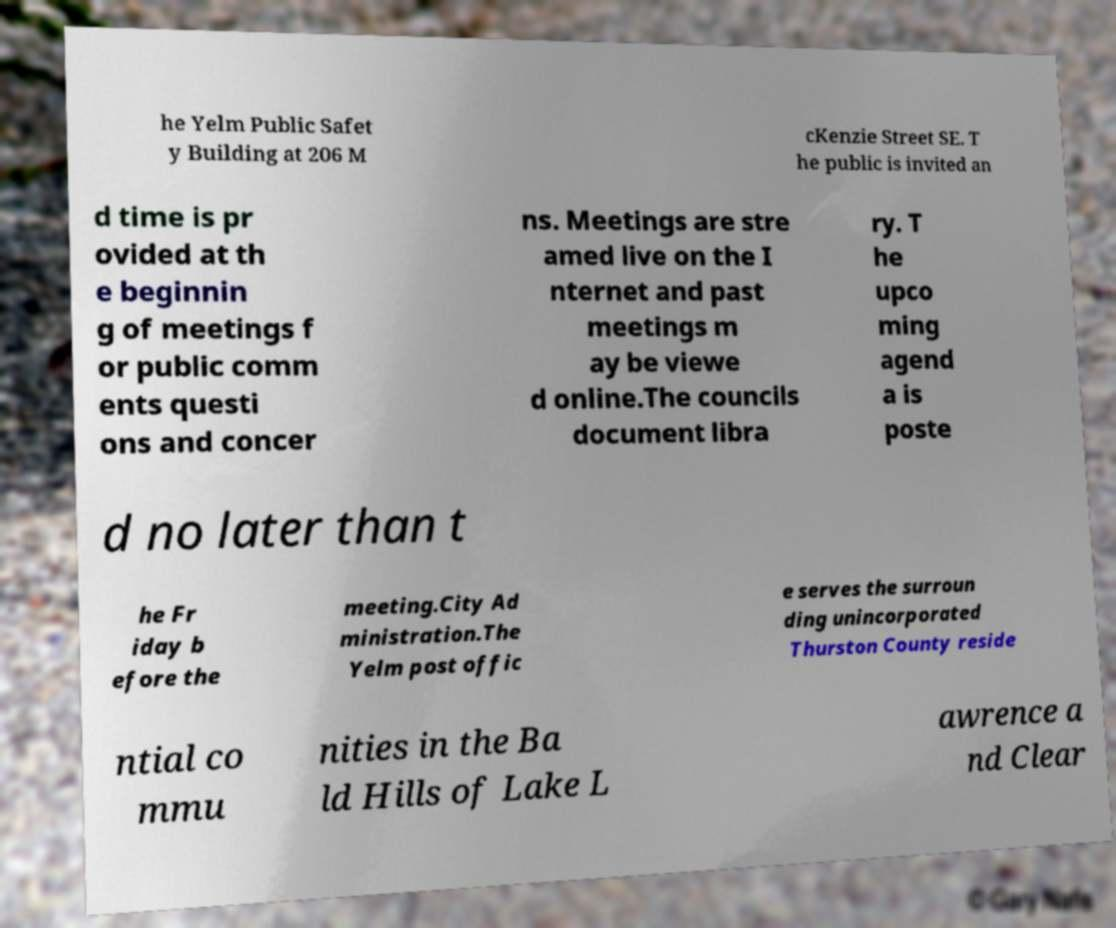For documentation purposes, I need the text within this image transcribed. Could you provide that? he Yelm Public Safet y Building at 206 M cKenzie Street SE. T he public is invited an d time is pr ovided at th e beginnin g of meetings f or public comm ents questi ons and concer ns. Meetings are stre amed live on the I nternet and past meetings m ay be viewe d online.The councils document libra ry. T he upco ming agend a is poste d no later than t he Fr iday b efore the meeting.City Ad ministration.The Yelm post offic e serves the surroun ding unincorporated Thurston County reside ntial co mmu nities in the Ba ld Hills of Lake L awrence a nd Clear 